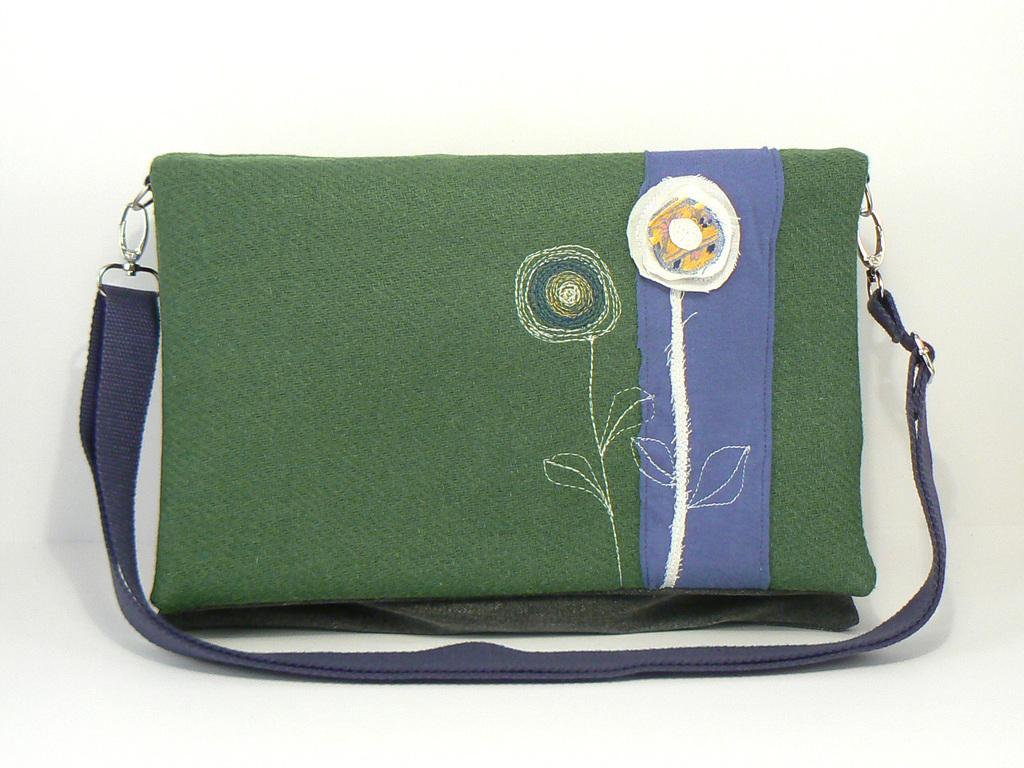Could you give a brief overview of what you see in this image? In this image I can see a bag and a handmade flower on it. 